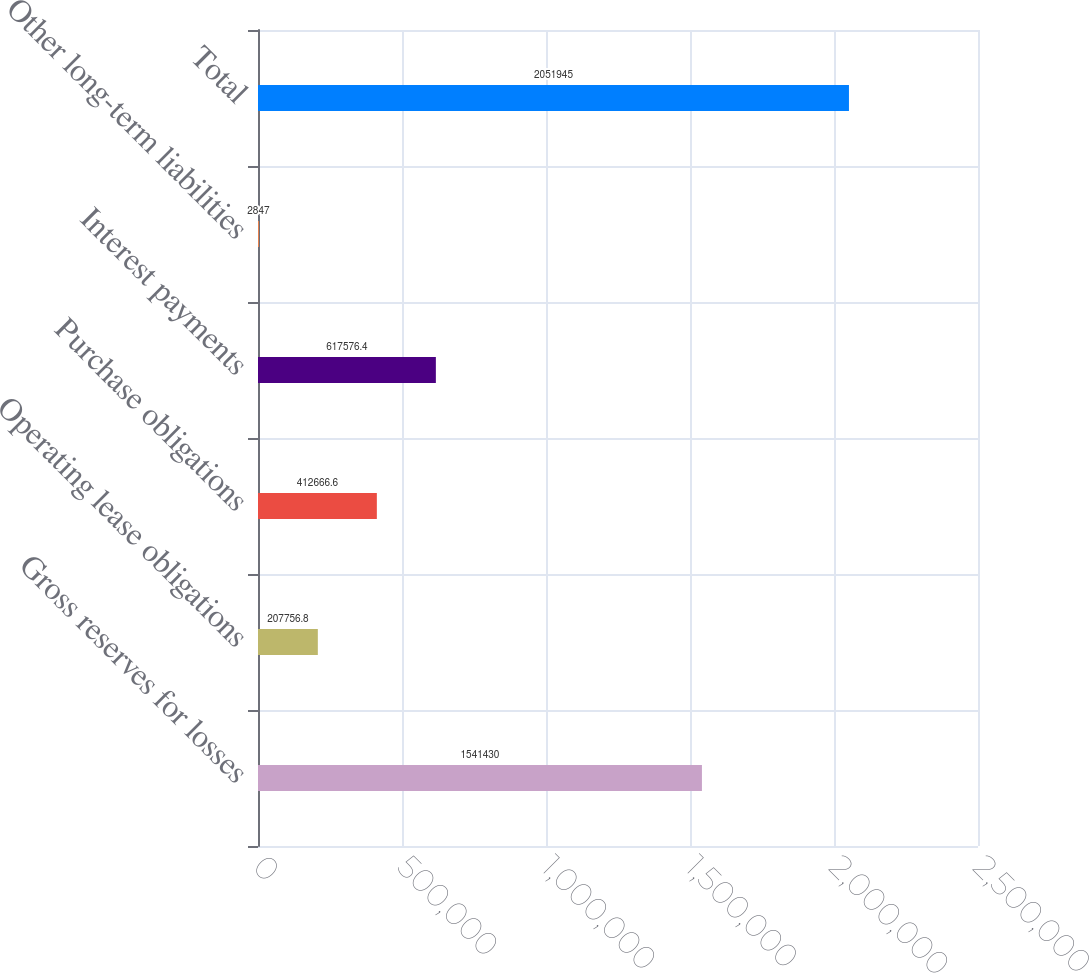Convert chart. <chart><loc_0><loc_0><loc_500><loc_500><bar_chart><fcel>Gross reserves for losses<fcel>Operating lease obligations<fcel>Purchase obligations<fcel>Interest payments<fcel>Other long-term liabilities<fcel>Total<nl><fcel>1.54143e+06<fcel>207757<fcel>412667<fcel>617576<fcel>2847<fcel>2.05194e+06<nl></chart> 